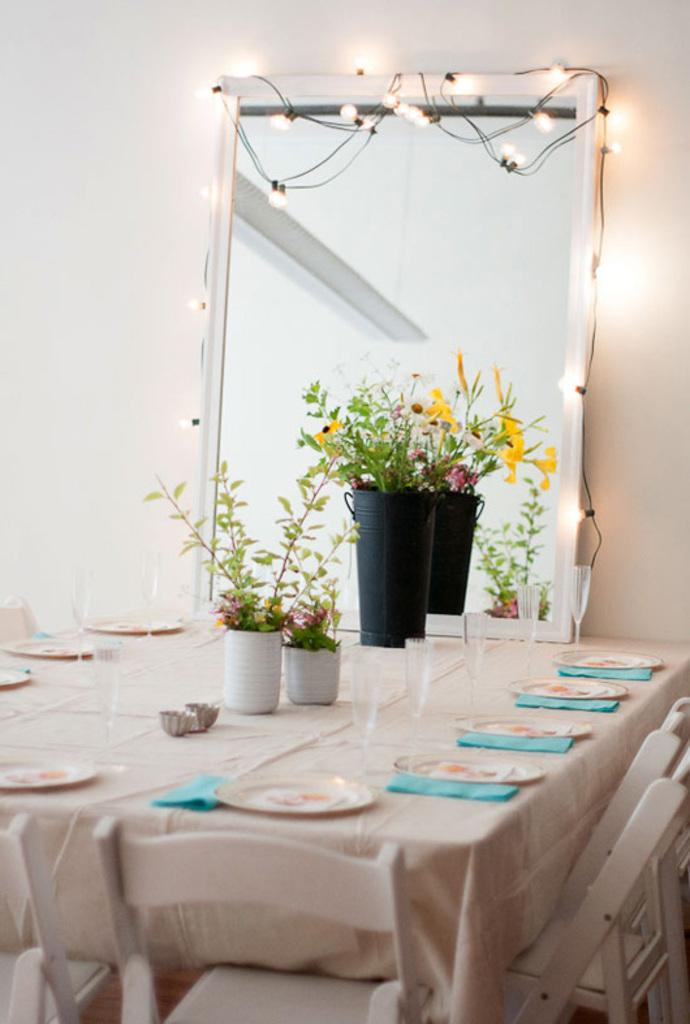What is the main piece of furniture in the image? There is a table in the image. What is placed on the table? Plants, plates, and tissues are placed on the table. What is used for seating around the table? There are chairs around the table. What can be seen in the background of the image? There is a mirror and a wall in the background of the image. What type of flame can be seen coming from the cars in the image? There are no cars or flames present in the image; it features a table with plants, plates, and tissues, surrounded by chairs, and has a mirror and a wall in the background. 